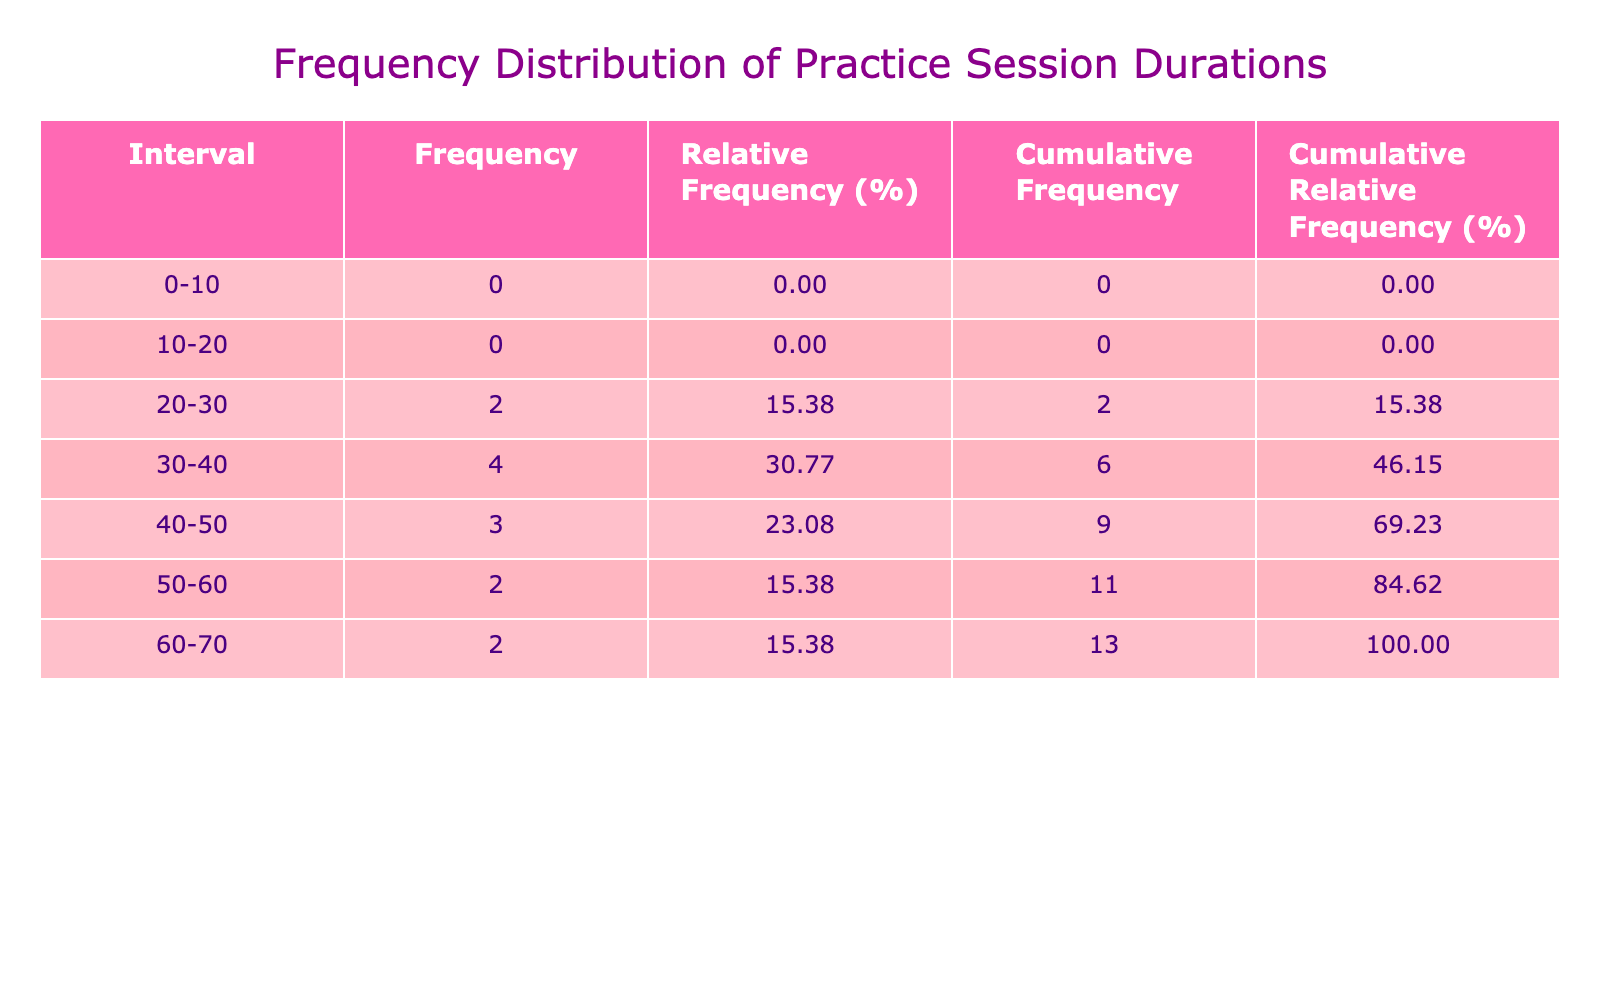What is the frequency of practice sessions lasting 50-60 minutes? Referring to the corresponding row in the frequency distribution table, we see that the frequency for the interval 50-60 minutes is listed directly.
Answer: 2 What is the range of durations from the longest to the shortest practice sessions? The longest session is 70 minutes (Classical Indian Dance) and the shortest is 20 minutes (Pantomime). Thus, the range is 70 - 20 = 50 minutes.
Answer: 50 minutes Is there a movement type that has a duration of exactly 45 minutes? Looking through the movement types listed in the table, we find that both Contemporary Dance and Modern Dance have durations of 45 minutes. Therefore, the statement is true.
Answer: Yes What is the cumulative relative frequency for practice sessions lasting 30-40 minutes? First, we sum the relative frequencies for the intervals 30-40 minutes. The intervals are 30-40, which has a frequency of 2, contributing 15.38% and the interval 40-50 contributes 15.38%. Adding both gives us a cumulative relative frequency of 30.77%.
Answer: 30.77% What is the average duration of all practice sessions? To find the average duration, we first sum all individual durations: (30 + 45 + 40 + 35 + 50 + 25 + 60 + 55 + 45 + 70 + 20 + 30 + 38) =  650 minutes. Then, we divide by the number of movements (13): 650/13 = 50 minutes.
Answer: 50 minutes Which type of movement has the highest duration and what is that duration? Reviewing the table, the maximum duration represents Classical Indian Dance with a duration of 70 minutes.
Answer: Classical Indian Dance, 70 minutes How many different movement types have durations of less than 35 minutes? We inspect the table to find that there are two movements with durations under 35 minutes: Tap Dance (25 minutes) and Pantomime (20 minutes).
Answer: 2 What is the total frequency of practice sessions that last between 40 and 50 minutes? We look at the frequency for the interval 40-50 minutes from the table, which indicates a frequency of 3 and aggregate that with the next interval, 50-60 minutes, which has a frequency of 2, yielding a total of 5 sessions.
Answer: 5 sessions 